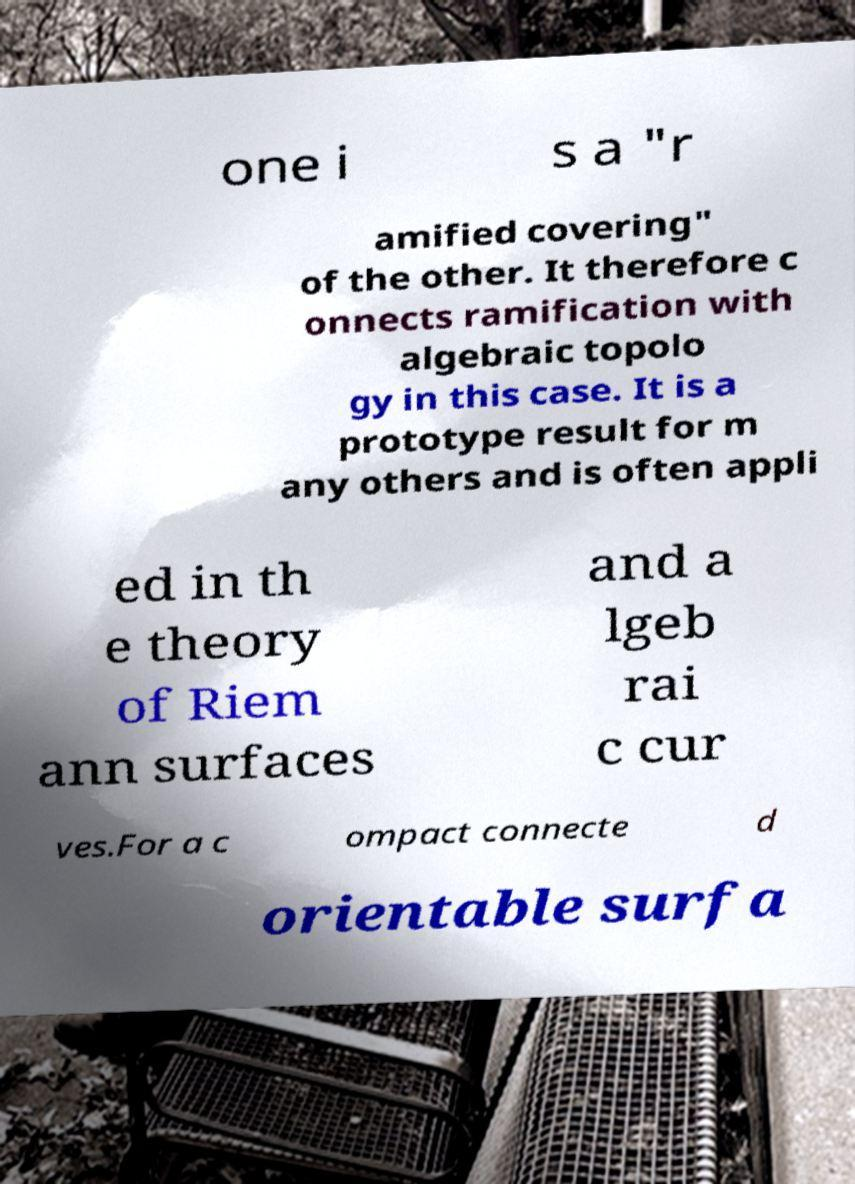Could you assist in decoding the text presented in this image and type it out clearly? one i s a "r amified covering" of the other. It therefore c onnects ramification with algebraic topolo gy in this case. It is a prototype result for m any others and is often appli ed in th e theory of Riem ann surfaces and a lgeb rai c cur ves.For a c ompact connecte d orientable surfa 